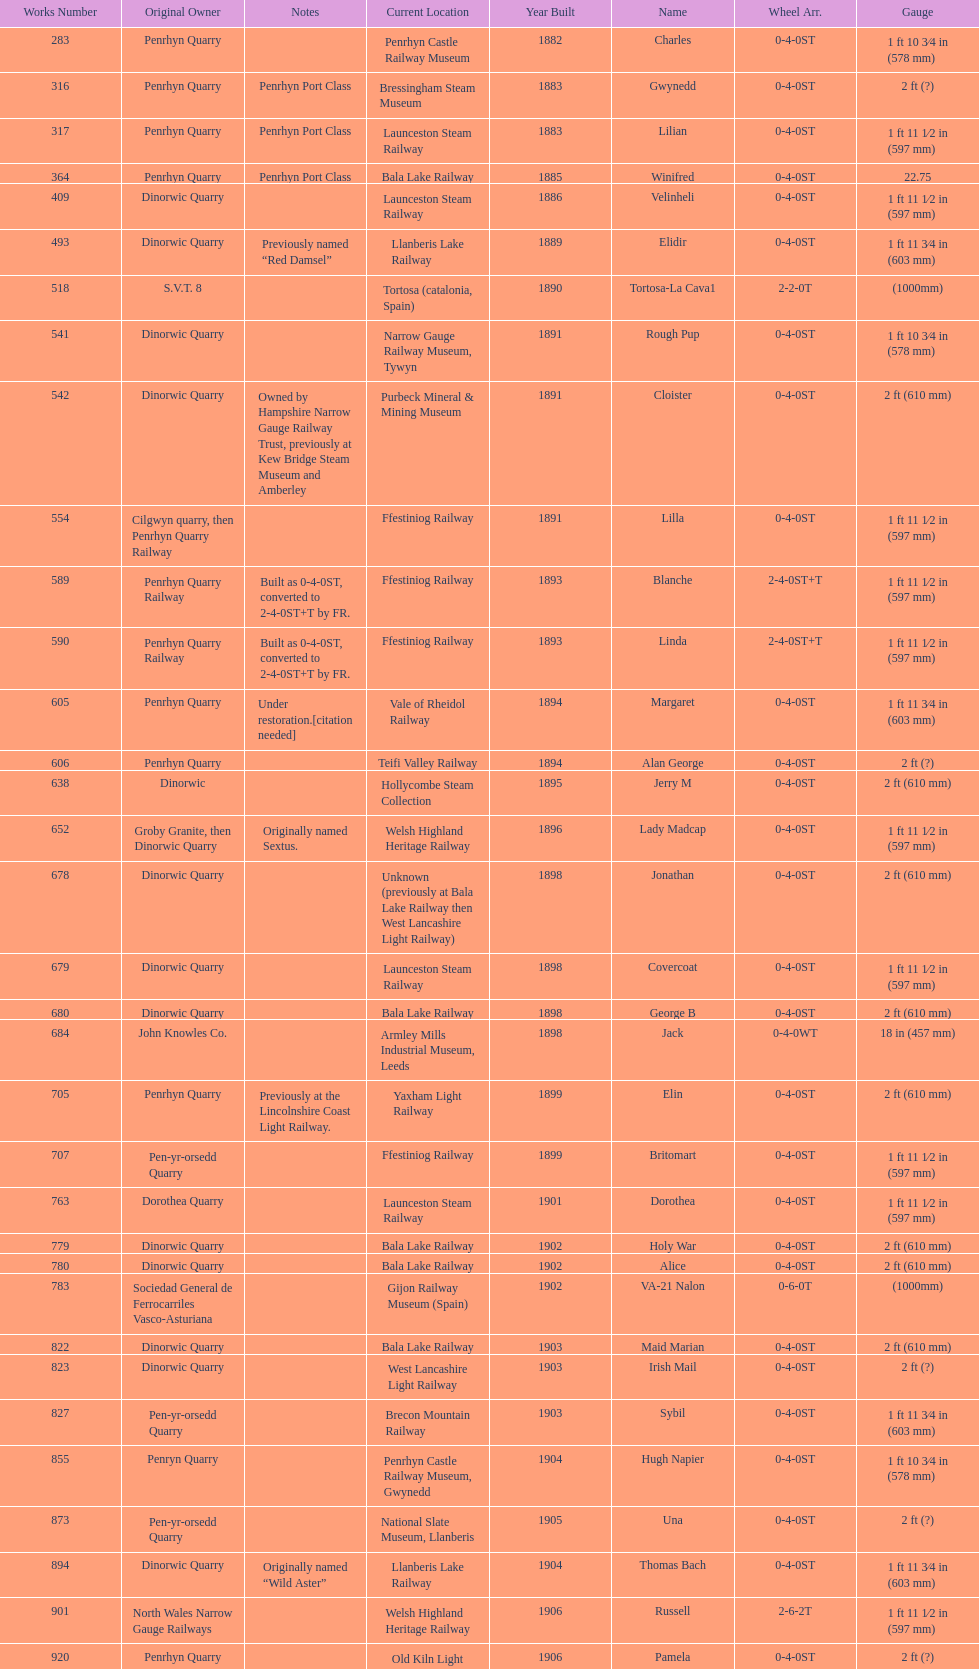After 1940, how many steam locomotives were built? 2. 